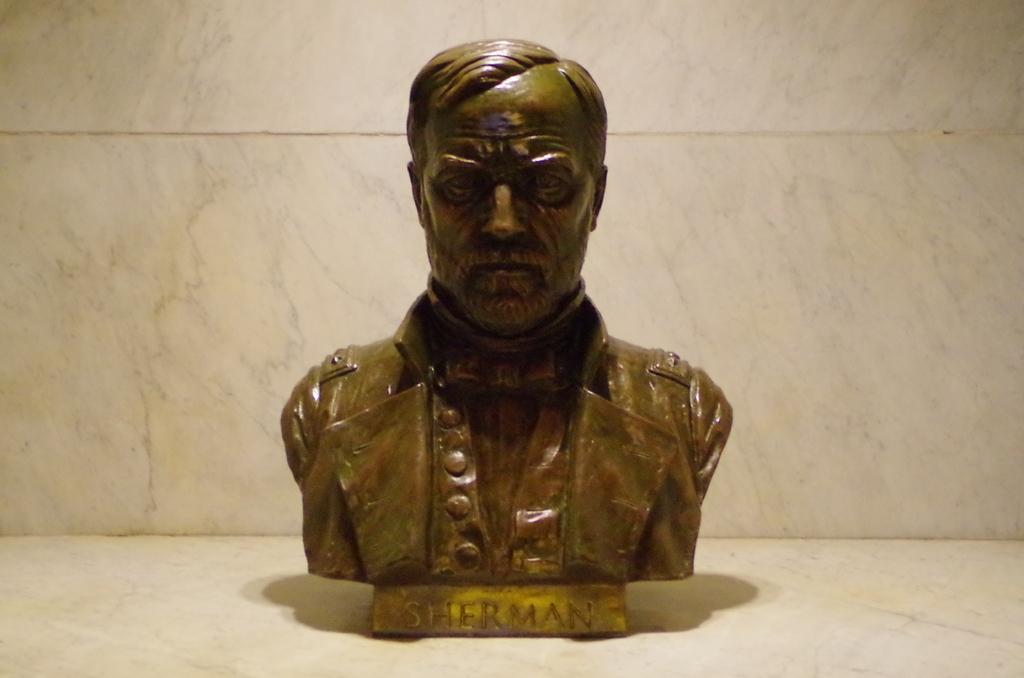How would you summarize this image in a sentence or two? In the middle of this image, there is a statue of a person on the floor. In the background, there is a white wall. 